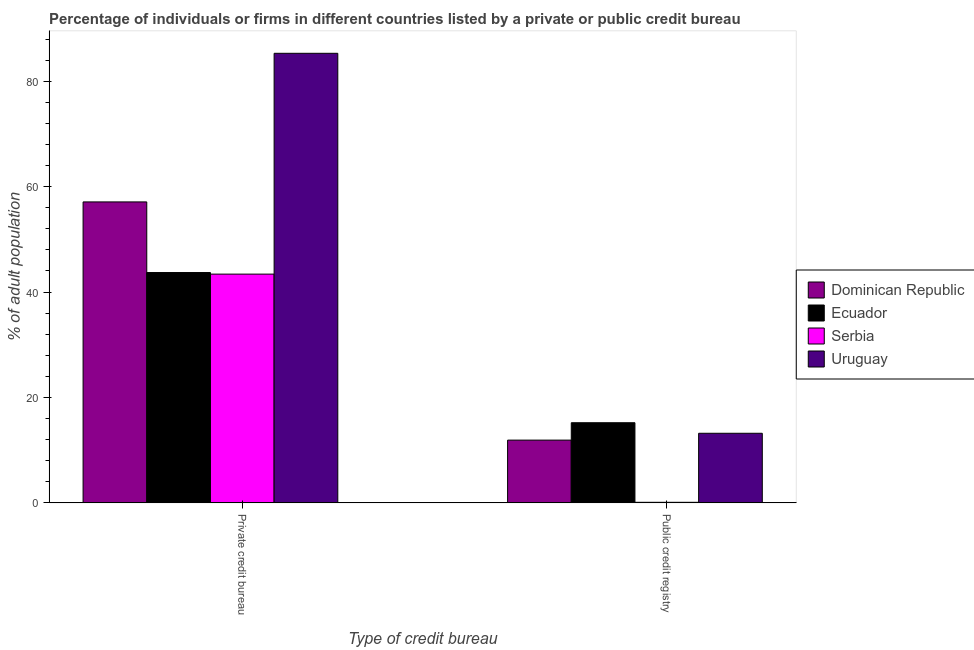How many groups of bars are there?
Offer a terse response. 2. How many bars are there on the 2nd tick from the left?
Ensure brevity in your answer.  4. How many bars are there on the 1st tick from the right?
Provide a short and direct response. 4. What is the label of the 2nd group of bars from the left?
Provide a short and direct response. Public credit registry. What is the percentage of firms listed by private credit bureau in Uruguay?
Your answer should be very brief. 85.3. Across all countries, what is the maximum percentage of firms listed by public credit bureau?
Ensure brevity in your answer.  15.2. Across all countries, what is the minimum percentage of firms listed by private credit bureau?
Your response must be concise. 43.4. In which country was the percentage of firms listed by public credit bureau maximum?
Offer a very short reply. Ecuador. In which country was the percentage of firms listed by private credit bureau minimum?
Offer a terse response. Serbia. What is the total percentage of firms listed by private credit bureau in the graph?
Offer a terse response. 229.5. What is the difference between the percentage of firms listed by private credit bureau in Dominican Republic and that in Uruguay?
Your response must be concise. -28.2. What is the difference between the percentage of firms listed by private credit bureau in Serbia and the percentage of firms listed by public credit bureau in Dominican Republic?
Keep it short and to the point. 31.5. What is the average percentage of firms listed by public credit bureau per country?
Your answer should be compact. 10.1. What is the difference between the percentage of firms listed by public credit bureau and percentage of firms listed by private credit bureau in Uruguay?
Your answer should be compact. -72.1. In how many countries, is the percentage of firms listed by private credit bureau greater than 56 %?
Your response must be concise. 2. What is the ratio of the percentage of firms listed by private credit bureau in Uruguay to that in Dominican Republic?
Provide a short and direct response. 1.49. What does the 2nd bar from the left in Public credit registry represents?
Give a very brief answer. Ecuador. What does the 3rd bar from the right in Public credit registry represents?
Offer a very short reply. Ecuador. How many bars are there?
Your response must be concise. 8. How many countries are there in the graph?
Provide a short and direct response. 4. What is the difference between two consecutive major ticks on the Y-axis?
Make the answer very short. 20. Does the graph contain any zero values?
Your answer should be compact. No. Does the graph contain grids?
Your answer should be compact. No. How many legend labels are there?
Provide a succinct answer. 4. How are the legend labels stacked?
Offer a terse response. Vertical. What is the title of the graph?
Keep it short and to the point. Percentage of individuals or firms in different countries listed by a private or public credit bureau. What is the label or title of the X-axis?
Make the answer very short. Type of credit bureau. What is the label or title of the Y-axis?
Your answer should be very brief. % of adult population. What is the % of adult population in Dominican Republic in Private credit bureau?
Give a very brief answer. 57.1. What is the % of adult population in Ecuador in Private credit bureau?
Provide a short and direct response. 43.7. What is the % of adult population in Serbia in Private credit bureau?
Make the answer very short. 43.4. What is the % of adult population in Uruguay in Private credit bureau?
Your answer should be compact. 85.3. What is the % of adult population of Ecuador in Public credit registry?
Give a very brief answer. 15.2. What is the % of adult population of Serbia in Public credit registry?
Provide a succinct answer. 0.1. What is the % of adult population of Uruguay in Public credit registry?
Make the answer very short. 13.2. Across all Type of credit bureau, what is the maximum % of adult population in Dominican Republic?
Give a very brief answer. 57.1. Across all Type of credit bureau, what is the maximum % of adult population in Ecuador?
Your answer should be very brief. 43.7. Across all Type of credit bureau, what is the maximum % of adult population in Serbia?
Make the answer very short. 43.4. Across all Type of credit bureau, what is the maximum % of adult population of Uruguay?
Offer a terse response. 85.3. Across all Type of credit bureau, what is the minimum % of adult population of Dominican Republic?
Provide a succinct answer. 11.9. Across all Type of credit bureau, what is the minimum % of adult population in Serbia?
Offer a terse response. 0.1. Across all Type of credit bureau, what is the minimum % of adult population in Uruguay?
Your answer should be compact. 13.2. What is the total % of adult population of Dominican Republic in the graph?
Provide a short and direct response. 69. What is the total % of adult population of Ecuador in the graph?
Make the answer very short. 58.9. What is the total % of adult population of Serbia in the graph?
Offer a terse response. 43.5. What is the total % of adult population in Uruguay in the graph?
Your answer should be very brief. 98.5. What is the difference between the % of adult population of Dominican Republic in Private credit bureau and that in Public credit registry?
Keep it short and to the point. 45.2. What is the difference between the % of adult population of Serbia in Private credit bureau and that in Public credit registry?
Your response must be concise. 43.3. What is the difference between the % of adult population in Uruguay in Private credit bureau and that in Public credit registry?
Provide a short and direct response. 72.1. What is the difference between the % of adult population in Dominican Republic in Private credit bureau and the % of adult population in Ecuador in Public credit registry?
Provide a succinct answer. 41.9. What is the difference between the % of adult population in Dominican Republic in Private credit bureau and the % of adult population in Serbia in Public credit registry?
Keep it short and to the point. 57. What is the difference between the % of adult population in Dominican Republic in Private credit bureau and the % of adult population in Uruguay in Public credit registry?
Offer a very short reply. 43.9. What is the difference between the % of adult population of Ecuador in Private credit bureau and the % of adult population of Serbia in Public credit registry?
Provide a short and direct response. 43.6. What is the difference between the % of adult population of Ecuador in Private credit bureau and the % of adult population of Uruguay in Public credit registry?
Ensure brevity in your answer.  30.5. What is the difference between the % of adult population of Serbia in Private credit bureau and the % of adult population of Uruguay in Public credit registry?
Give a very brief answer. 30.2. What is the average % of adult population in Dominican Republic per Type of credit bureau?
Your response must be concise. 34.5. What is the average % of adult population in Ecuador per Type of credit bureau?
Keep it short and to the point. 29.45. What is the average % of adult population of Serbia per Type of credit bureau?
Provide a succinct answer. 21.75. What is the average % of adult population in Uruguay per Type of credit bureau?
Your answer should be very brief. 49.25. What is the difference between the % of adult population in Dominican Republic and % of adult population in Uruguay in Private credit bureau?
Give a very brief answer. -28.2. What is the difference between the % of adult population of Ecuador and % of adult population of Serbia in Private credit bureau?
Offer a very short reply. 0.3. What is the difference between the % of adult population of Ecuador and % of adult population of Uruguay in Private credit bureau?
Keep it short and to the point. -41.6. What is the difference between the % of adult population of Serbia and % of adult population of Uruguay in Private credit bureau?
Your response must be concise. -41.9. What is the difference between the % of adult population in Dominican Republic and % of adult population in Ecuador in Public credit registry?
Provide a short and direct response. -3.3. What is the difference between the % of adult population of Dominican Republic and % of adult population of Uruguay in Public credit registry?
Your answer should be compact. -1.3. What is the difference between the % of adult population of Ecuador and % of adult population of Uruguay in Public credit registry?
Provide a short and direct response. 2. What is the difference between the % of adult population in Serbia and % of adult population in Uruguay in Public credit registry?
Provide a short and direct response. -13.1. What is the ratio of the % of adult population in Dominican Republic in Private credit bureau to that in Public credit registry?
Your answer should be very brief. 4.8. What is the ratio of the % of adult population of Ecuador in Private credit bureau to that in Public credit registry?
Ensure brevity in your answer.  2.88. What is the ratio of the % of adult population in Serbia in Private credit bureau to that in Public credit registry?
Ensure brevity in your answer.  434. What is the ratio of the % of adult population in Uruguay in Private credit bureau to that in Public credit registry?
Provide a short and direct response. 6.46. What is the difference between the highest and the second highest % of adult population of Dominican Republic?
Make the answer very short. 45.2. What is the difference between the highest and the second highest % of adult population in Ecuador?
Offer a terse response. 28.5. What is the difference between the highest and the second highest % of adult population in Serbia?
Provide a succinct answer. 43.3. What is the difference between the highest and the second highest % of adult population in Uruguay?
Your response must be concise. 72.1. What is the difference between the highest and the lowest % of adult population of Dominican Republic?
Provide a short and direct response. 45.2. What is the difference between the highest and the lowest % of adult population of Ecuador?
Provide a succinct answer. 28.5. What is the difference between the highest and the lowest % of adult population of Serbia?
Keep it short and to the point. 43.3. What is the difference between the highest and the lowest % of adult population of Uruguay?
Keep it short and to the point. 72.1. 